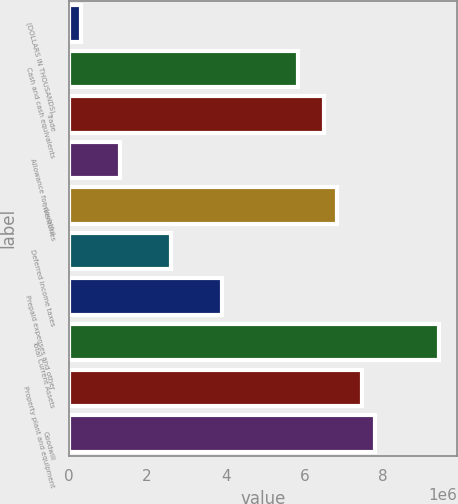Convert chart. <chart><loc_0><loc_0><loc_500><loc_500><bar_chart><fcel>(DOLLARS IN THOUSANDS)<fcel>Cash and cash equivalents<fcel>Trade<fcel>Allowance for doubtful<fcel>Inventories<fcel>Deferred income taxes<fcel>Prepaid expenses and other<fcel>Total Current Assets<fcel>Property plant and equipment<fcel>Goodwill<nl><fcel>325156<fcel>5.84911e+06<fcel>6.49898e+06<fcel>1.29997e+06<fcel>6.82392e+06<fcel>2.59972e+06<fcel>3.89948e+06<fcel>9.42343e+06<fcel>7.4738e+06<fcel>7.79873e+06<nl></chart> 